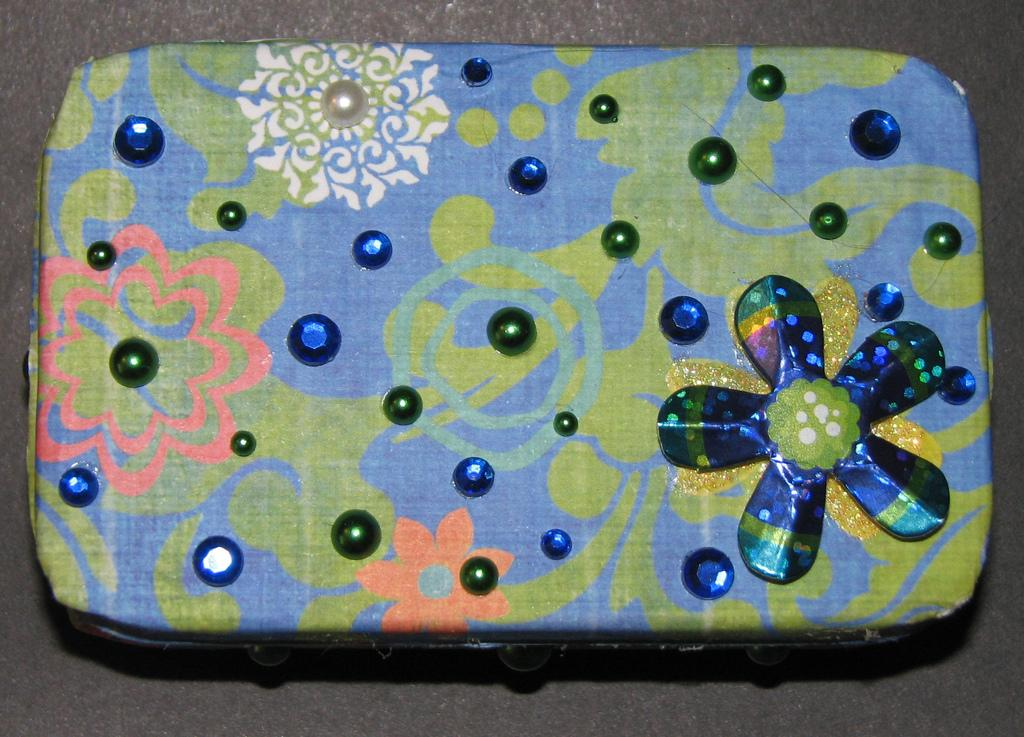What object is in the image that is not a part of the cloth? There is a box in the image. What is covering the box? Cloth is present on the box. What is depicted on the cloth? There is some art on the cloth. What is the color of the surface the box is placed on? The box is placed on a black surface. What type of wood is used to make the pies in the image? There are no pies present in the image, and therefore no wood is used to make them. What type of tank can be seen in the image? There is no tank present in the image. 